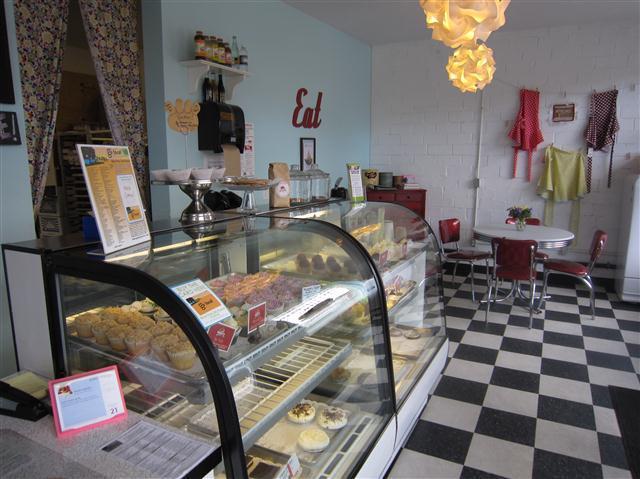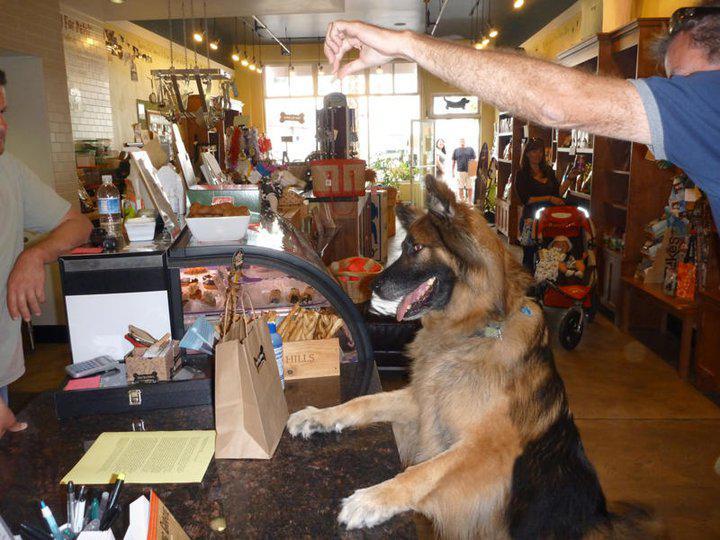The first image is the image on the left, the second image is the image on the right. Assess this claim about the two images: "One person is standing alone in front of a wooden counter and at least one person is somewhere behind the counter in one image.". Correct or not? Answer yes or no. No. 